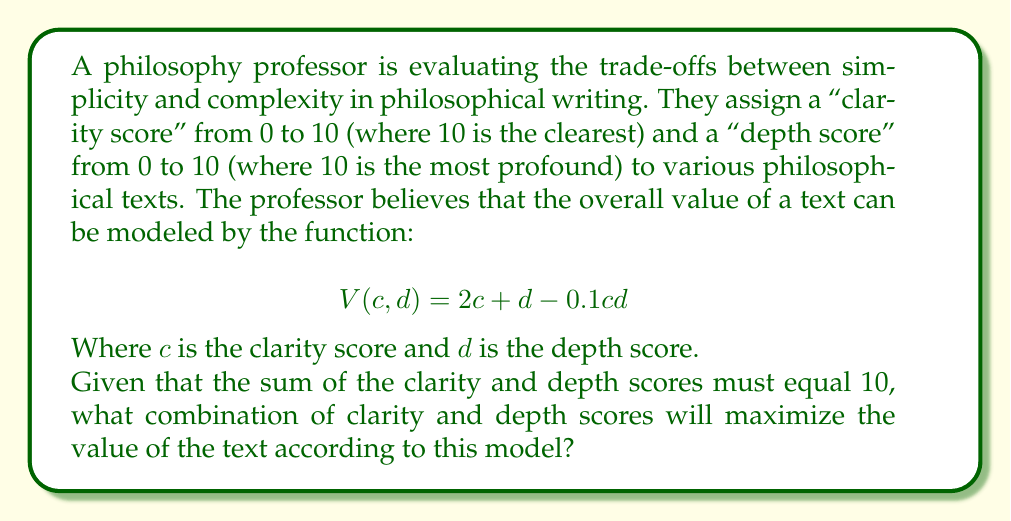Show me your answer to this math problem. To solve this problem, we can use optimization techniques from operations research. Let's approach this step-by-step:

1) We're given that $c + d = 10$, so we can express $d$ in terms of $c$:
   $d = 10 - c$

2) Substituting this into our value function:
   $$V(c) = 2c + (10-c) - 0.1c(10-c)$$
   $$V(c) = 2c + 10 - c - c + 0.1c^2$$
   $$V(c) = 10 + c + 0.1c^2$$

3) To find the maximum value, we need to find where the derivative of $V(c)$ equals zero:
   $$\frac{dV}{dc} = 1 + 0.2c$$

4) Setting this equal to zero:
   $$1 + 0.2c = 0$$
   $$0.2c = -1$$
   $$c = -5$$

5) However, $c = -5$ is outside our valid range (0 to 10). This means our maximum must occur at one of the endpoints of our range.

6) Let's evaluate $V(c)$ at $c = 0$ and $c = 10$:
   $$V(0) = 10 + 0 + 0.1(0)^2 = 10$$
   $$V(10) = 10 + 10 + 0.1(10)^2 = 30$$

7) Clearly, $V(10)$ is larger. This means the maximum value occurs when the clarity score is 10 and the depth score is 0.

This result suggests that, according to this model, maximum clarity (simplicity) is preferred over depth (complexity) in philosophical writing.
Answer: The optimal combination is a clarity score of 10 and a depth score of 0, yielding a maximum value of 30. 